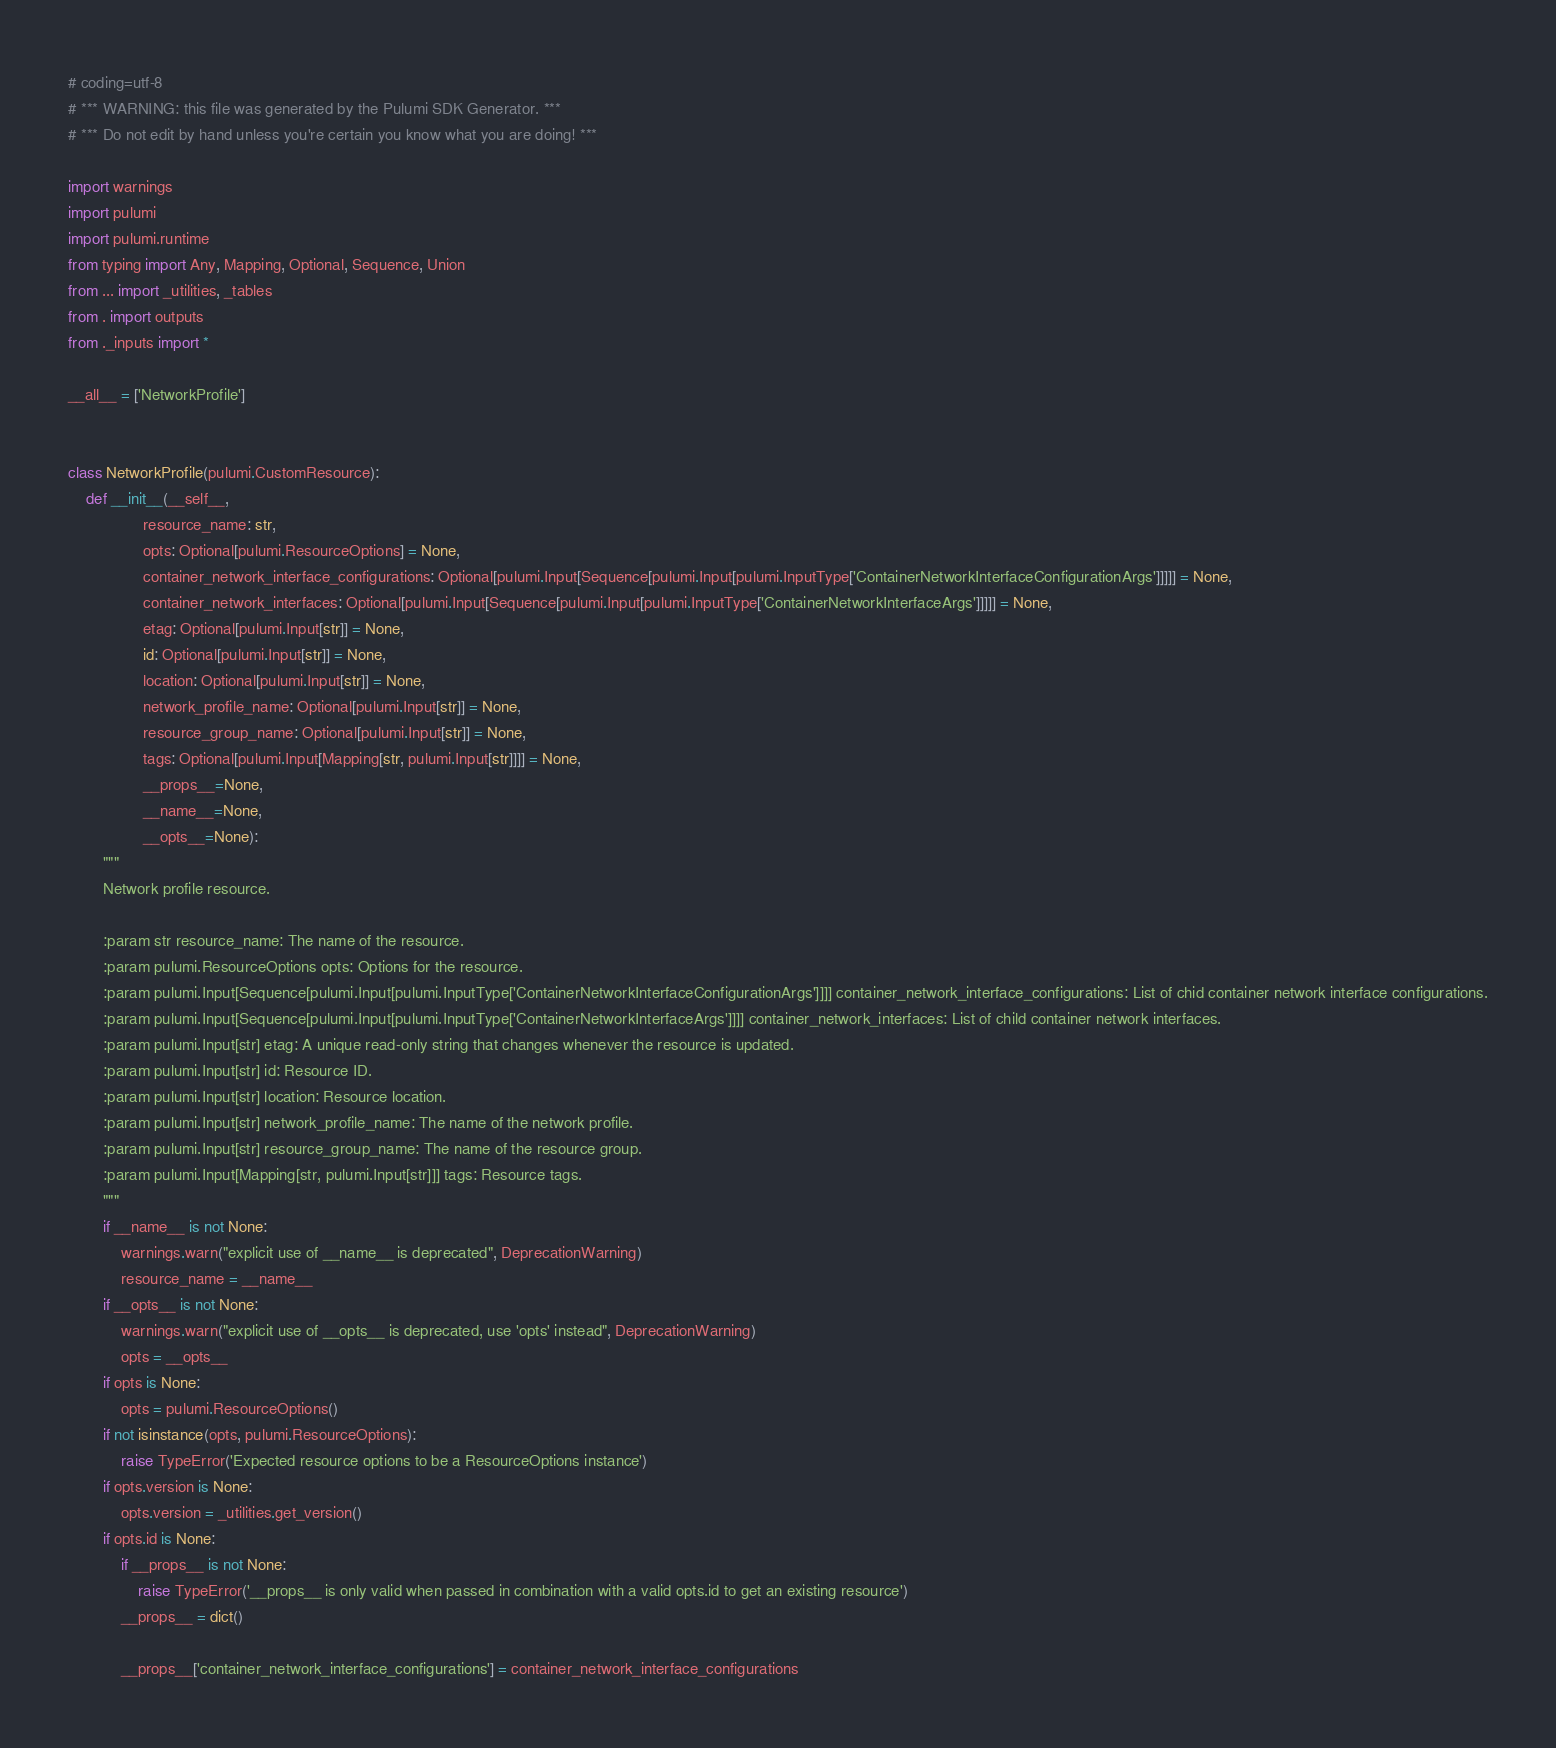<code> <loc_0><loc_0><loc_500><loc_500><_Python_># coding=utf-8
# *** WARNING: this file was generated by the Pulumi SDK Generator. ***
# *** Do not edit by hand unless you're certain you know what you are doing! ***

import warnings
import pulumi
import pulumi.runtime
from typing import Any, Mapping, Optional, Sequence, Union
from ... import _utilities, _tables
from . import outputs
from ._inputs import *

__all__ = ['NetworkProfile']


class NetworkProfile(pulumi.CustomResource):
    def __init__(__self__,
                 resource_name: str,
                 opts: Optional[pulumi.ResourceOptions] = None,
                 container_network_interface_configurations: Optional[pulumi.Input[Sequence[pulumi.Input[pulumi.InputType['ContainerNetworkInterfaceConfigurationArgs']]]]] = None,
                 container_network_interfaces: Optional[pulumi.Input[Sequence[pulumi.Input[pulumi.InputType['ContainerNetworkInterfaceArgs']]]]] = None,
                 etag: Optional[pulumi.Input[str]] = None,
                 id: Optional[pulumi.Input[str]] = None,
                 location: Optional[pulumi.Input[str]] = None,
                 network_profile_name: Optional[pulumi.Input[str]] = None,
                 resource_group_name: Optional[pulumi.Input[str]] = None,
                 tags: Optional[pulumi.Input[Mapping[str, pulumi.Input[str]]]] = None,
                 __props__=None,
                 __name__=None,
                 __opts__=None):
        """
        Network profile resource.

        :param str resource_name: The name of the resource.
        :param pulumi.ResourceOptions opts: Options for the resource.
        :param pulumi.Input[Sequence[pulumi.Input[pulumi.InputType['ContainerNetworkInterfaceConfigurationArgs']]]] container_network_interface_configurations: List of chid container network interface configurations.
        :param pulumi.Input[Sequence[pulumi.Input[pulumi.InputType['ContainerNetworkInterfaceArgs']]]] container_network_interfaces: List of child container network interfaces.
        :param pulumi.Input[str] etag: A unique read-only string that changes whenever the resource is updated.
        :param pulumi.Input[str] id: Resource ID.
        :param pulumi.Input[str] location: Resource location.
        :param pulumi.Input[str] network_profile_name: The name of the network profile.
        :param pulumi.Input[str] resource_group_name: The name of the resource group.
        :param pulumi.Input[Mapping[str, pulumi.Input[str]]] tags: Resource tags.
        """
        if __name__ is not None:
            warnings.warn("explicit use of __name__ is deprecated", DeprecationWarning)
            resource_name = __name__
        if __opts__ is not None:
            warnings.warn("explicit use of __opts__ is deprecated, use 'opts' instead", DeprecationWarning)
            opts = __opts__
        if opts is None:
            opts = pulumi.ResourceOptions()
        if not isinstance(opts, pulumi.ResourceOptions):
            raise TypeError('Expected resource options to be a ResourceOptions instance')
        if opts.version is None:
            opts.version = _utilities.get_version()
        if opts.id is None:
            if __props__ is not None:
                raise TypeError('__props__ is only valid when passed in combination with a valid opts.id to get an existing resource')
            __props__ = dict()

            __props__['container_network_interface_configurations'] = container_network_interface_configurations</code> 